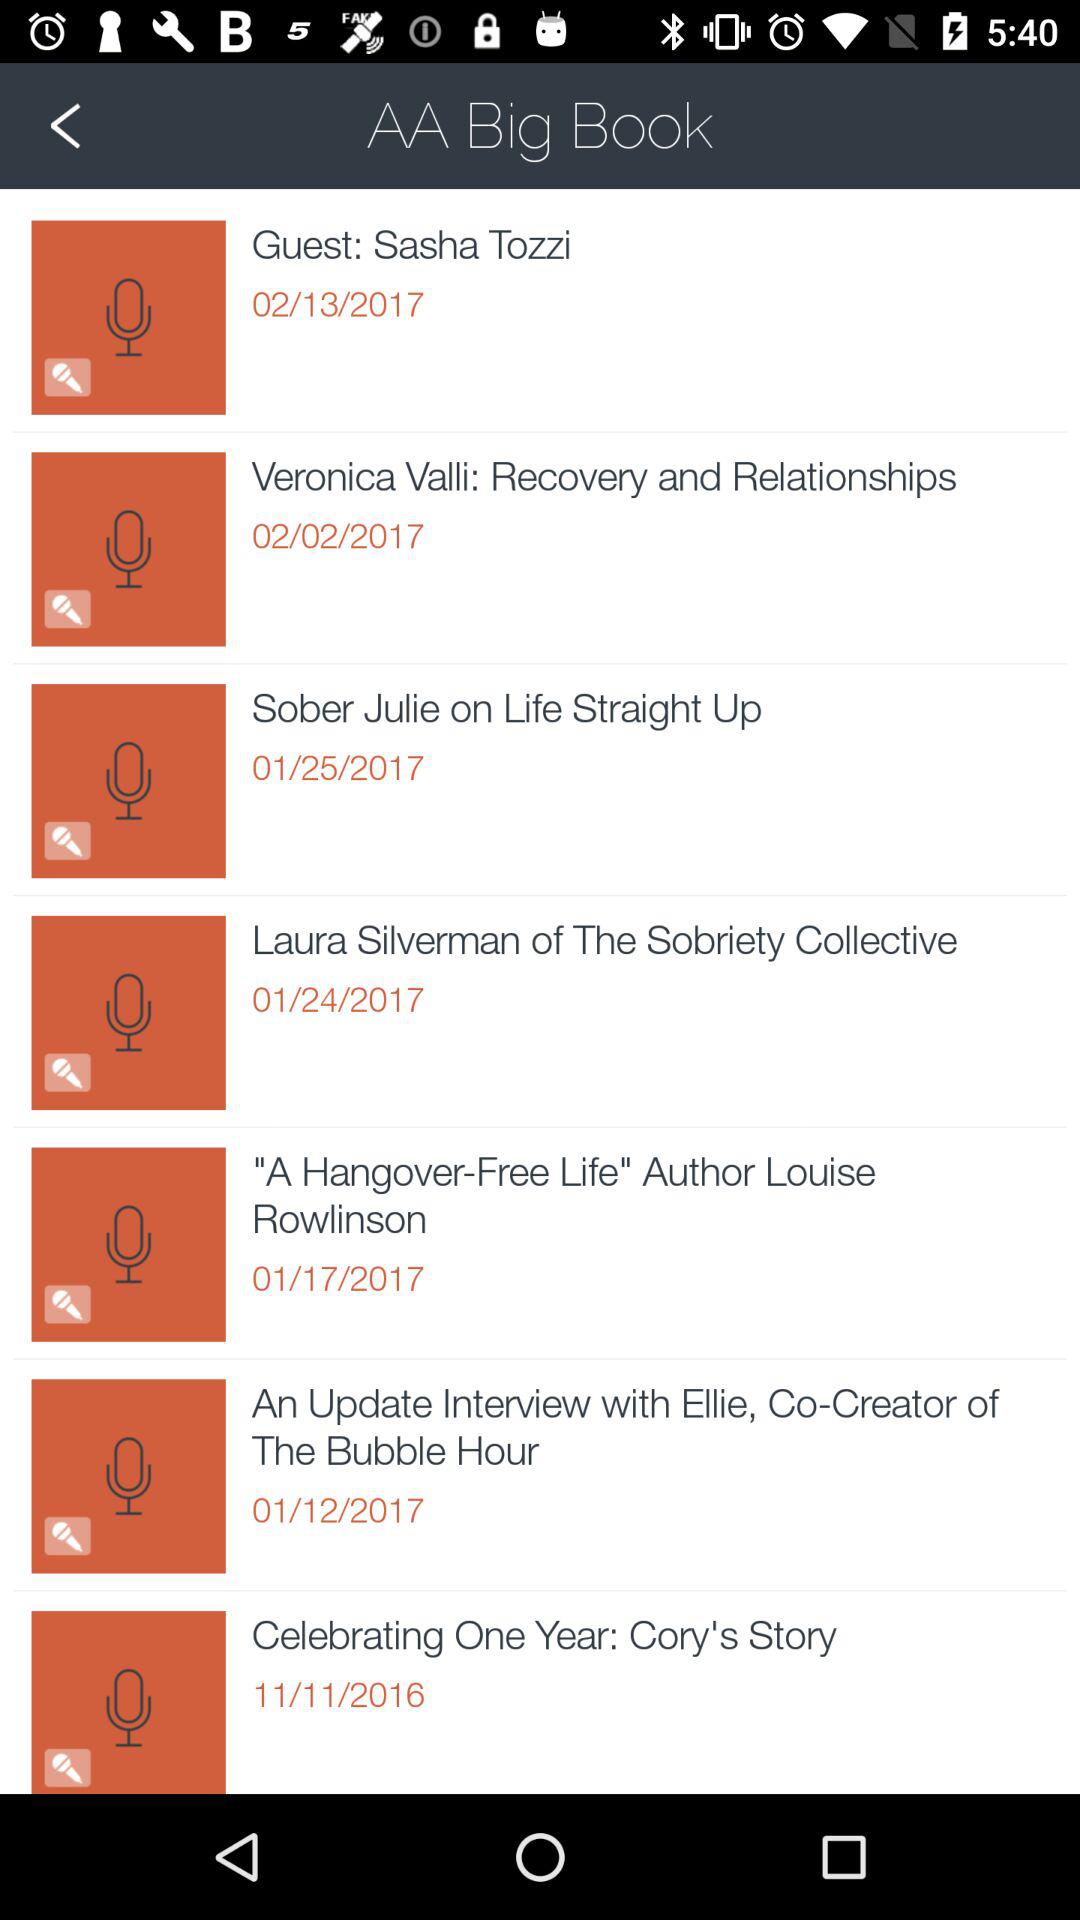What is the name of the application? The name of the application is "AA Big Book". 